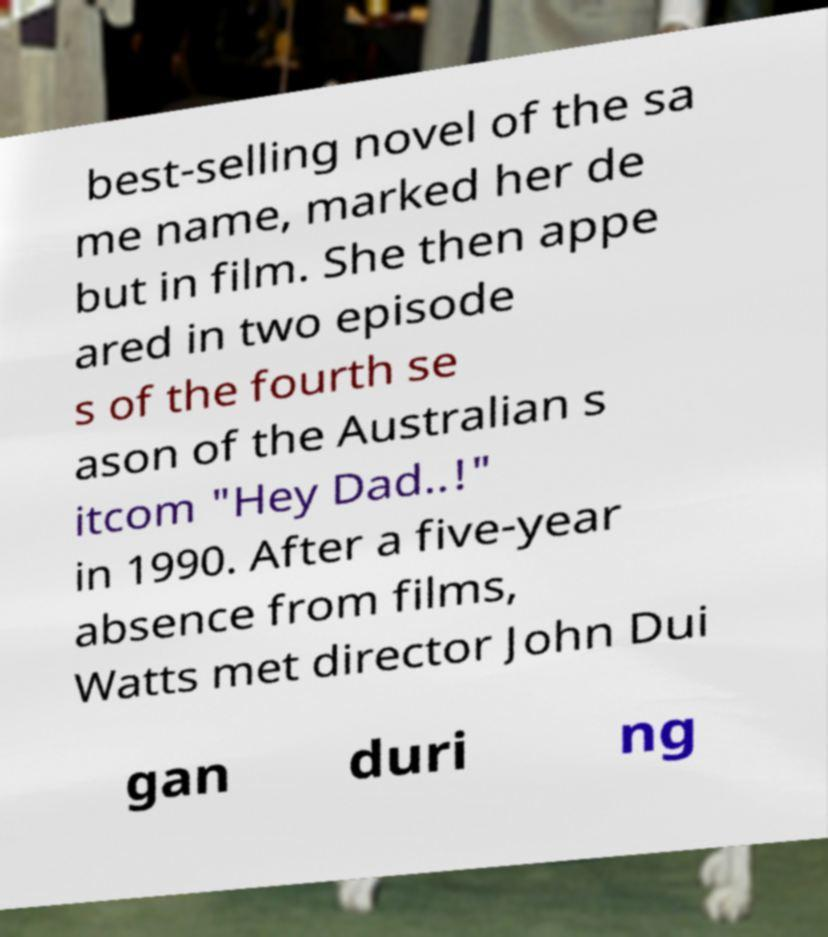I need the written content from this picture converted into text. Can you do that? best-selling novel of the sa me name, marked her de but in film. She then appe ared in two episode s of the fourth se ason of the Australian s itcom "Hey Dad..!" in 1990. After a five-year absence from films, Watts met director John Dui gan duri ng 